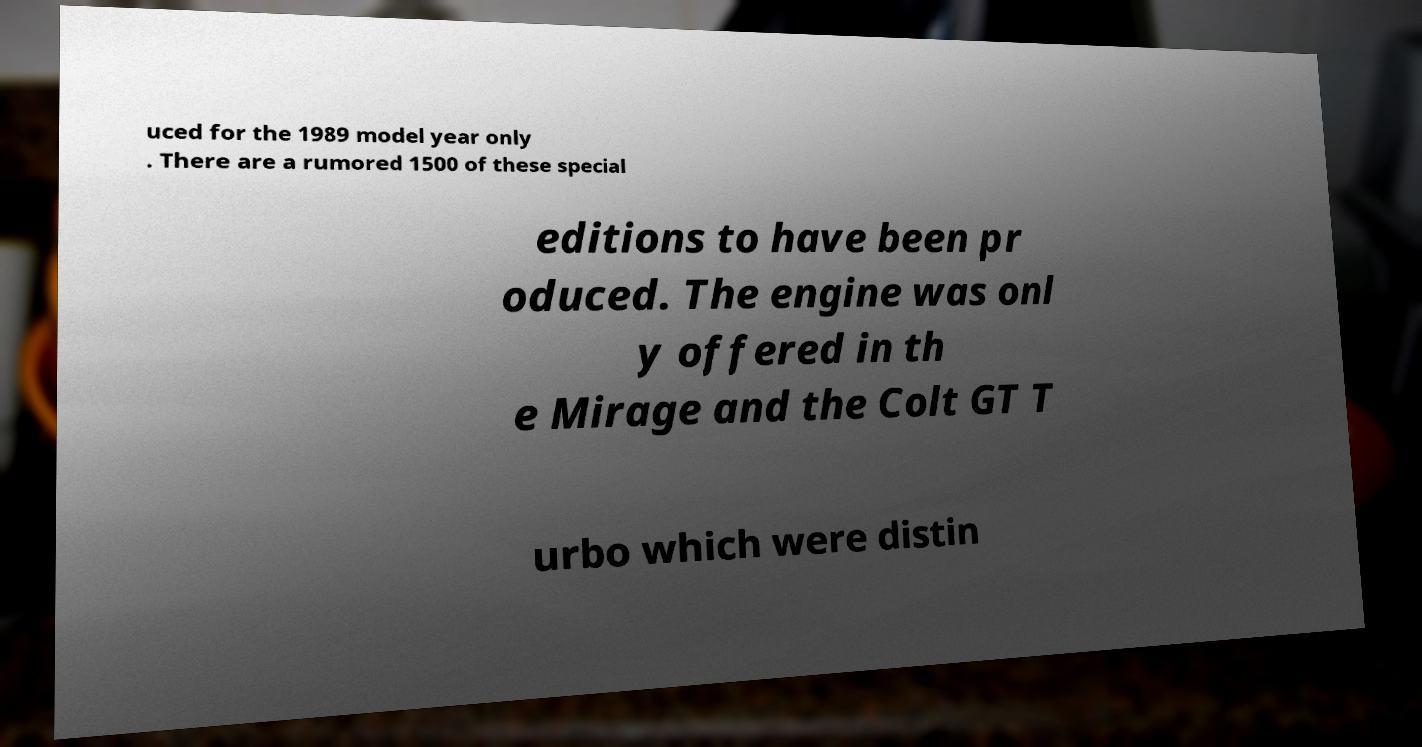Please read and relay the text visible in this image. What does it say? uced for the 1989 model year only . There are a rumored 1500 of these special editions to have been pr oduced. The engine was onl y offered in th e Mirage and the Colt GT T urbo which were distin 